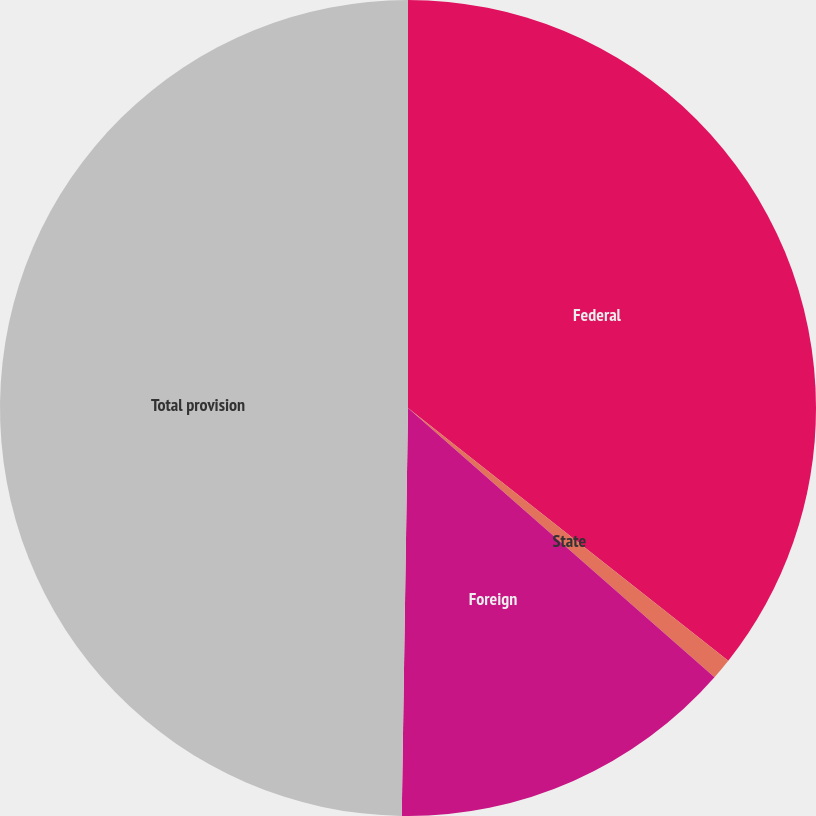Convert chart to OTSL. <chart><loc_0><loc_0><loc_500><loc_500><pie_chart><fcel>Federal<fcel>State<fcel>Foreign<fcel>Total provision<nl><fcel>35.63%<fcel>0.84%<fcel>13.77%<fcel>49.75%<nl></chart> 